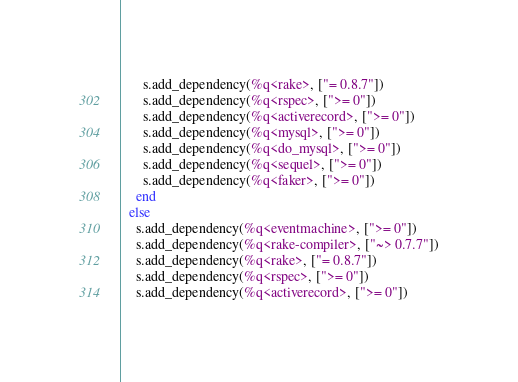<code> <loc_0><loc_0><loc_500><loc_500><_Ruby_>      s.add_dependency(%q<rake>, ["= 0.8.7"])
      s.add_dependency(%q<rspec>, [">= 0"])
      s.add_dependency(%q<activerecord>, [">= 0"])
      s.add_dependency(%q<mysql>, [">= 0"])
      s.add_dependency(%q<do_mysql>, [">= 0"])
      s.add_dependency(%q<sequel>, [">= 0"])
      s.add_dependency(%q<faker>, [">= 0"])
    end
  else
    s.add_dependency(%q<eventmachine>, [">= 0"])
    s.add_dependency(%q<rake-compiler>, ["~> 0.7.7"])
    s.add_dependency(%q<rake>, ["= 0.8.7"])
    s.add_dependency(%q<rspec>, [">= 0"])
    s.add_dependency(%q<activerecord>, [">= 0"])</code> 